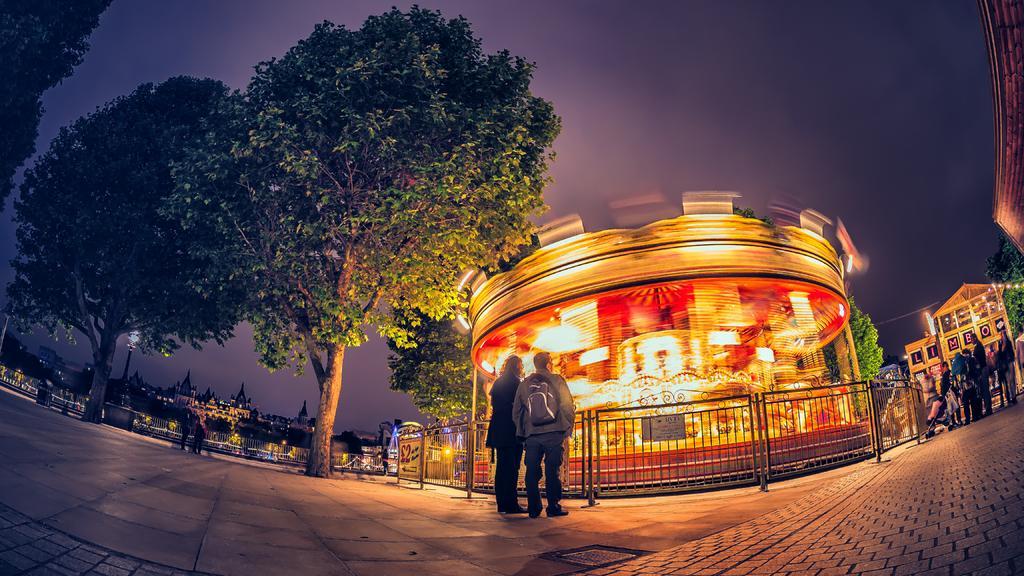Could you give a brief overview of what you see in this image? In this picture there are two persons standing near to the fencing. On the right we can see group of persons. Here it's a roller coaster. On the left background we can see water, fencing, street light, church and buildings. On the top there is a sky. 